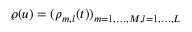<formula> <loc_0><loc_0><loc_500><loc_500>\varrho ( u ) = ( \rho _ { m , l } ( t ) ) _ { m = 1 , \dots , M , l = 1 , \dots , L }</formula> 